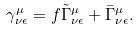<formula> <loc_0><loc_0><loc_500><loc_500>\gamma ^ { \mu } _ { \nu \epsilon } = f \tilde { \Gamma } ^ { \mu } _ { \nu \epsilon } + \bar { \Gamma } ^ { \mu } _ { \nu \epsilon } .</formula> 